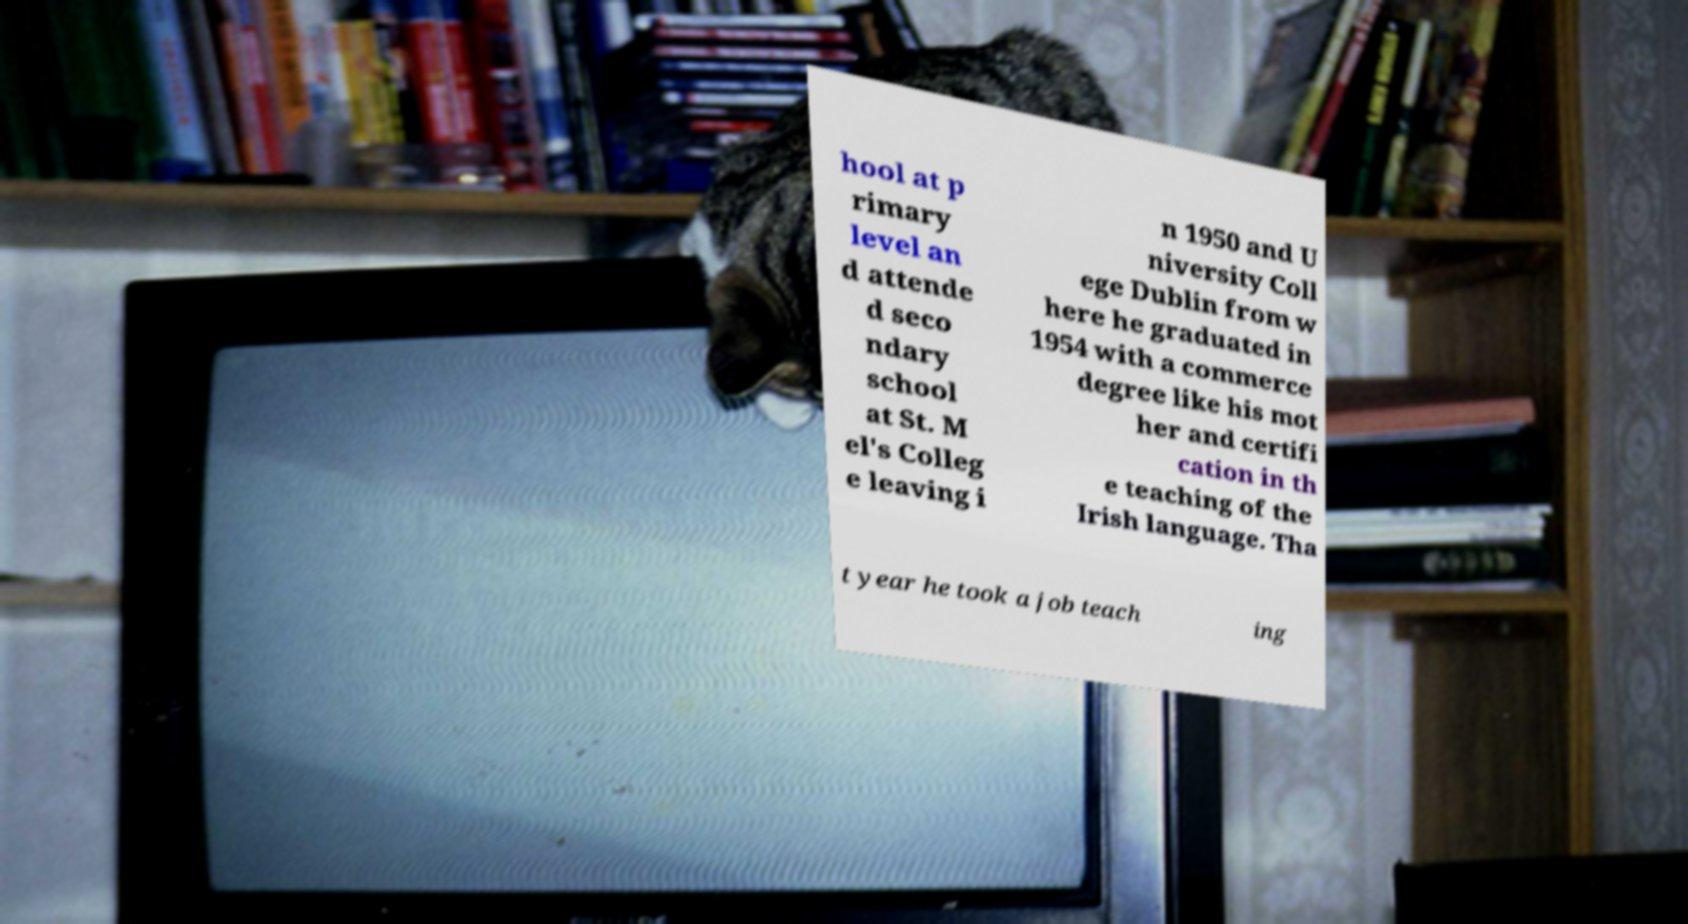There's text embedded in this image that I need extracted. Can you transcribe it verbatim? hool at p rimary level an d attende d seco ndary school at St. M el's Colleg e leaving i n 1950 and U niversity Coll ege Dublin from w here he graduated in 1954 with a commerce degree like his mot her and certifi cation in th e teaching of the Irish language. Tha t year he took a job teach ing 